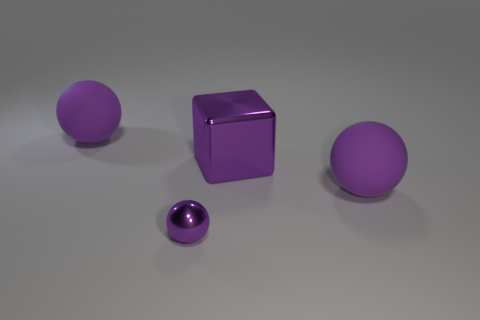Add 4 tiny cyan objects. How many objects exist? 8 Subtract all spheres. How many objects are left? 1 Add 2 tiny blue metal blocks. How many tiny blue metal blocks exist? 2 Subtract 0 red blocks. How many objects are left? 4 Subtract all big things. Subtract all large purple shiny objects. How many objects are left? 0 Add 3 big cubes. How many big cubes are left? 4 